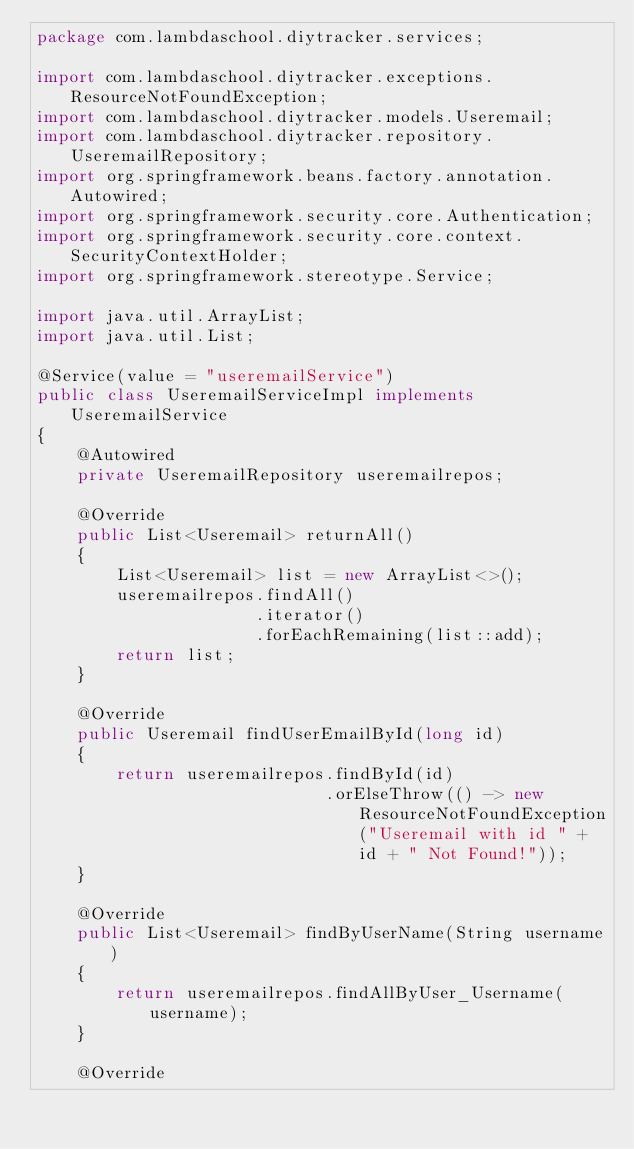<code> <loc_0><loc_0><loc_500><loc_500><_Java_>package com.lambdaschool.diytracker.services;

import com.lambdaschool.diytracker.exceptions.ResourceNotFoundException;
import com.lambdaschool.diytracker.models.Useremail;
import com.lambdaschool.diytracker.repository.UseremailRepository;
import org.springframework.beans.factory.annotation.Autowired;
import org.springframework.security.core.Authentication;
import org.springframework.security.core.context.SecurityContextHolder;
import org.springframework.stereotype.Service;

import java.util.ArrayList;
import java.util.List;

@Service(value = "useremailService")
public class UseremailServiceImpl implements UseremailService
{
    @Autowired
    private UseremailRepository useremailrepos;

    @Override
    public List<Useremail> returnAll()
    {
        List<Useremail> list = new ArrayList<>();
        useremailrepos.findAll()
                      .iterator()
                      .forEachRemaining(list::add);
        return list;
    }

    @Override
    public Useremail findUserEmailById(long id)
    {
        return useremailrepos.findById(id)
                             .orElseThrow(() -> new ResourceNotFoundException("Useremail with id " + id + " Not Found!"));
    }

    @Override
    public List<Useremail> findByUserName(String username)
    {
        return useremailrepos.findAllByUser_Username(username);
    }

    @Override</code> 